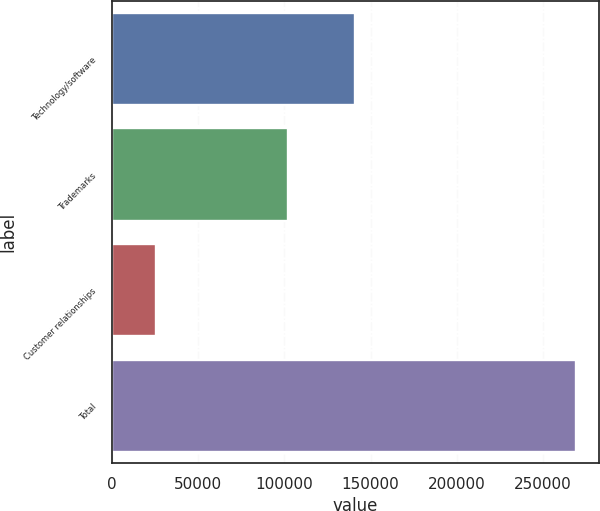Convert chart to OTSL. <chart><loc_0><loc_0><loc_500><loc_500><bar_chart><fcel>Technology/software<fcel>Trademarks<fcel>Customer relationships<fcel>Total<nl><fcel>140800<fcel>102220<fcel>25880<fcel>268950<nl></chart> 